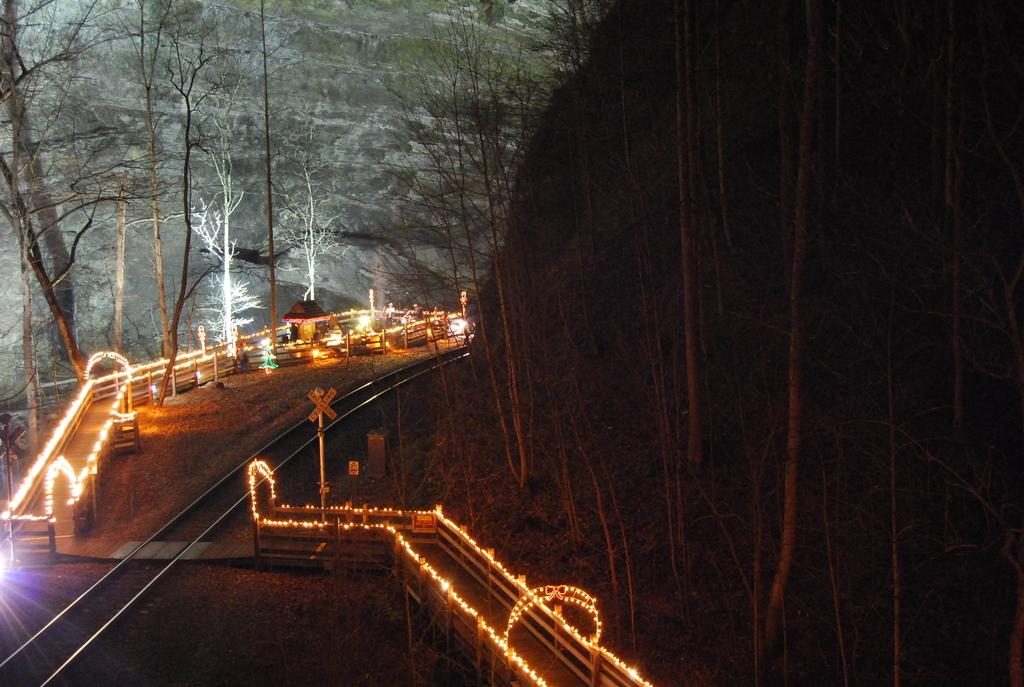What can be found in the bottom left corner of the image? In the bottom left corner of the image, there is fencing, lights, and poles. What is located in the middle of the image? There are trees in the middle of the image. Where is the stem of the tree located in the image? There is no stem of a tree present in the image; it is a general image of trees without focusing on a specific tree's stem. What type of nest can be seen in the image? There is no nest present in the image. 